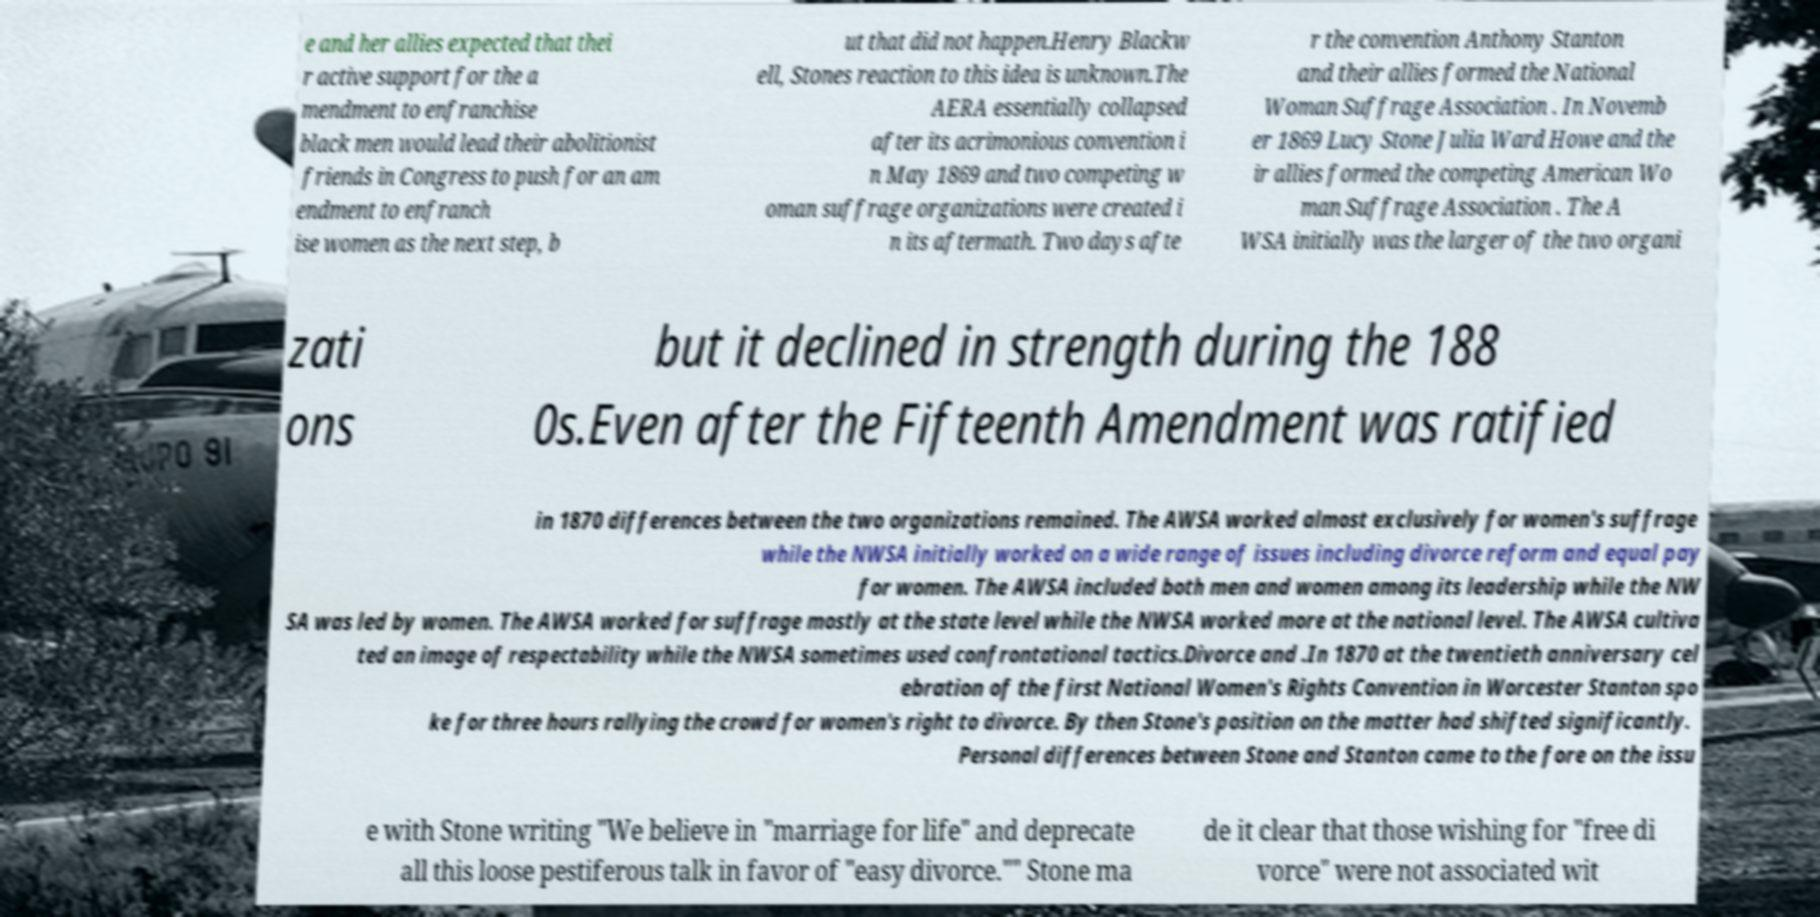There's text embedded in this image that I need extracted. Can you transcribe it verbatim? e and her allies expected that thei r active support for the a mendment to enfranchise black men would lead their abolitionist friends in Congress to push for an am endment to enfranch ise women as the next step, b ut that did not happen.Henry Blackw ell, Stones reaction to this idea is unknown.The AERA essentially collapsed after its acrimonious convention i n May 1869 and two competing w oman suffrage organizations were created i n its aftermath. Two days afte r the convention Anthony Stanton and their allies formed the National Woman Suffrage Association . In Novemb er 1869 Lucy Stone Julia Ward Howe and the ir allies formed the competing American Wo man Suffrage Association . The A WSA initially was the larger of the two organi zati ons but it declined in strength during the 188 0s.Even after the Fifteenth Amendment was ratified in 1870 differences between the two organizations remained. The AWSA worked almost exclusively for women's suffrage while the NWSA initially worked on a wide range of issues including divorce reform and equal pay for women. The AWSA included both men and women among its leadership while the NW SA was led by women. The AWSA worked for suffrage mostly at the state level while the NWSA worked more at the national level. The AWSA cultiva ted an image of respectability while the NWSA sometimes used confrontational tactics.Divorce and .In 1870 at the twentieth anniversary cel ebration of the first National Women's Rights Convention in Worcester Stanton spo ke for three hours rallying the crowd for women's right to divorce. By then Stone's position on the matter had shifted significantly. Personal differences between Stone and Stanton came to the fore on the issu e with Stone writing "We believe in "marriage for life" and deprecate all this loose pestiferous talk in favor of "easy divorce."" Stone ma de it clear that those wishing for "free di vorce" were not associated wit 